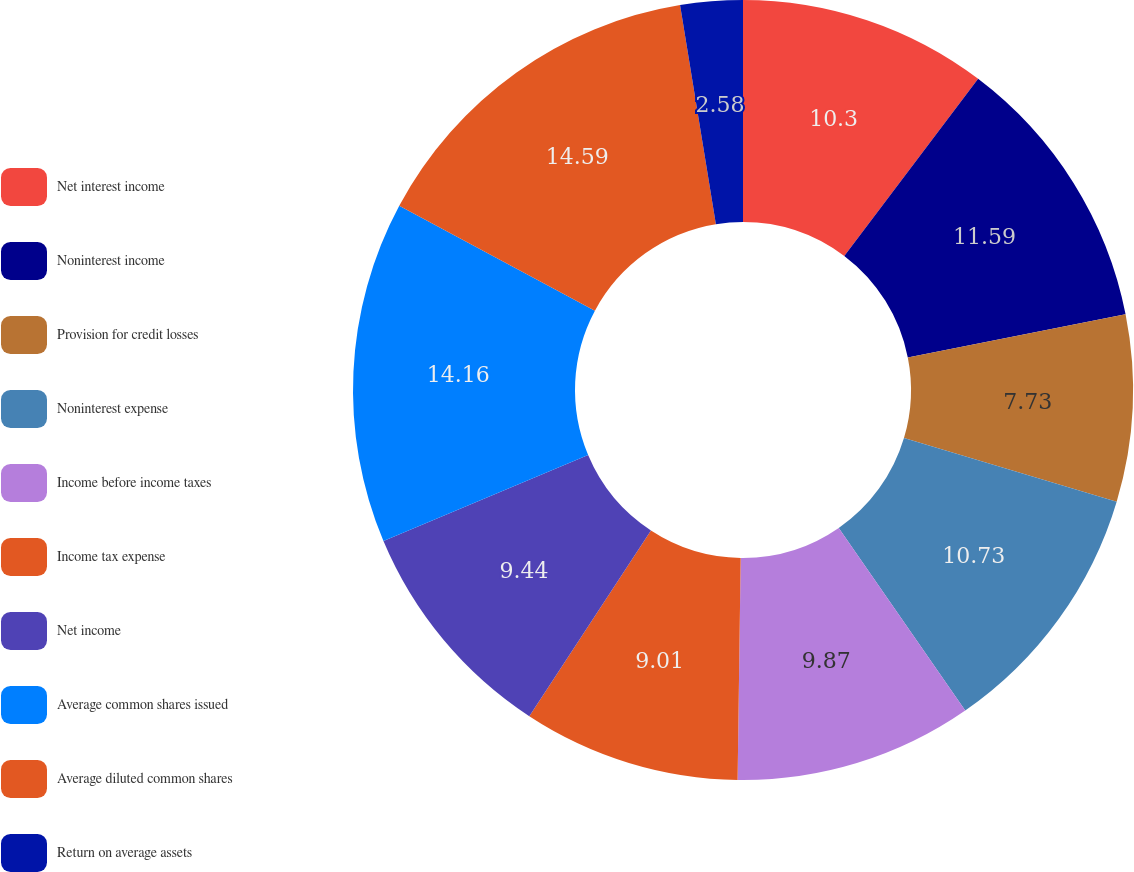<chart> <loc_0><loc_0><loc_500><loc_500><pie_chart><fcel>Net interest income<fcel>Noninterest income<fcel>Provision for credit losses<fcel>Noninterest expense<fcel>Income before income taxes<fcel>Income tax expense<fcel>Net income<fcel>Average common shares issued<fcel>Average diluted common shares<fcel>Return on average assets<nl><fcel>10.3%<fcel>11.59%<fcel>7.73%<fcel>10.73%<fcel>9.87%<fcel>9.01%<fcel>9.44%<fcel>14.16%<fcel>14.59%<fcel>2.58%<nl></chart> 